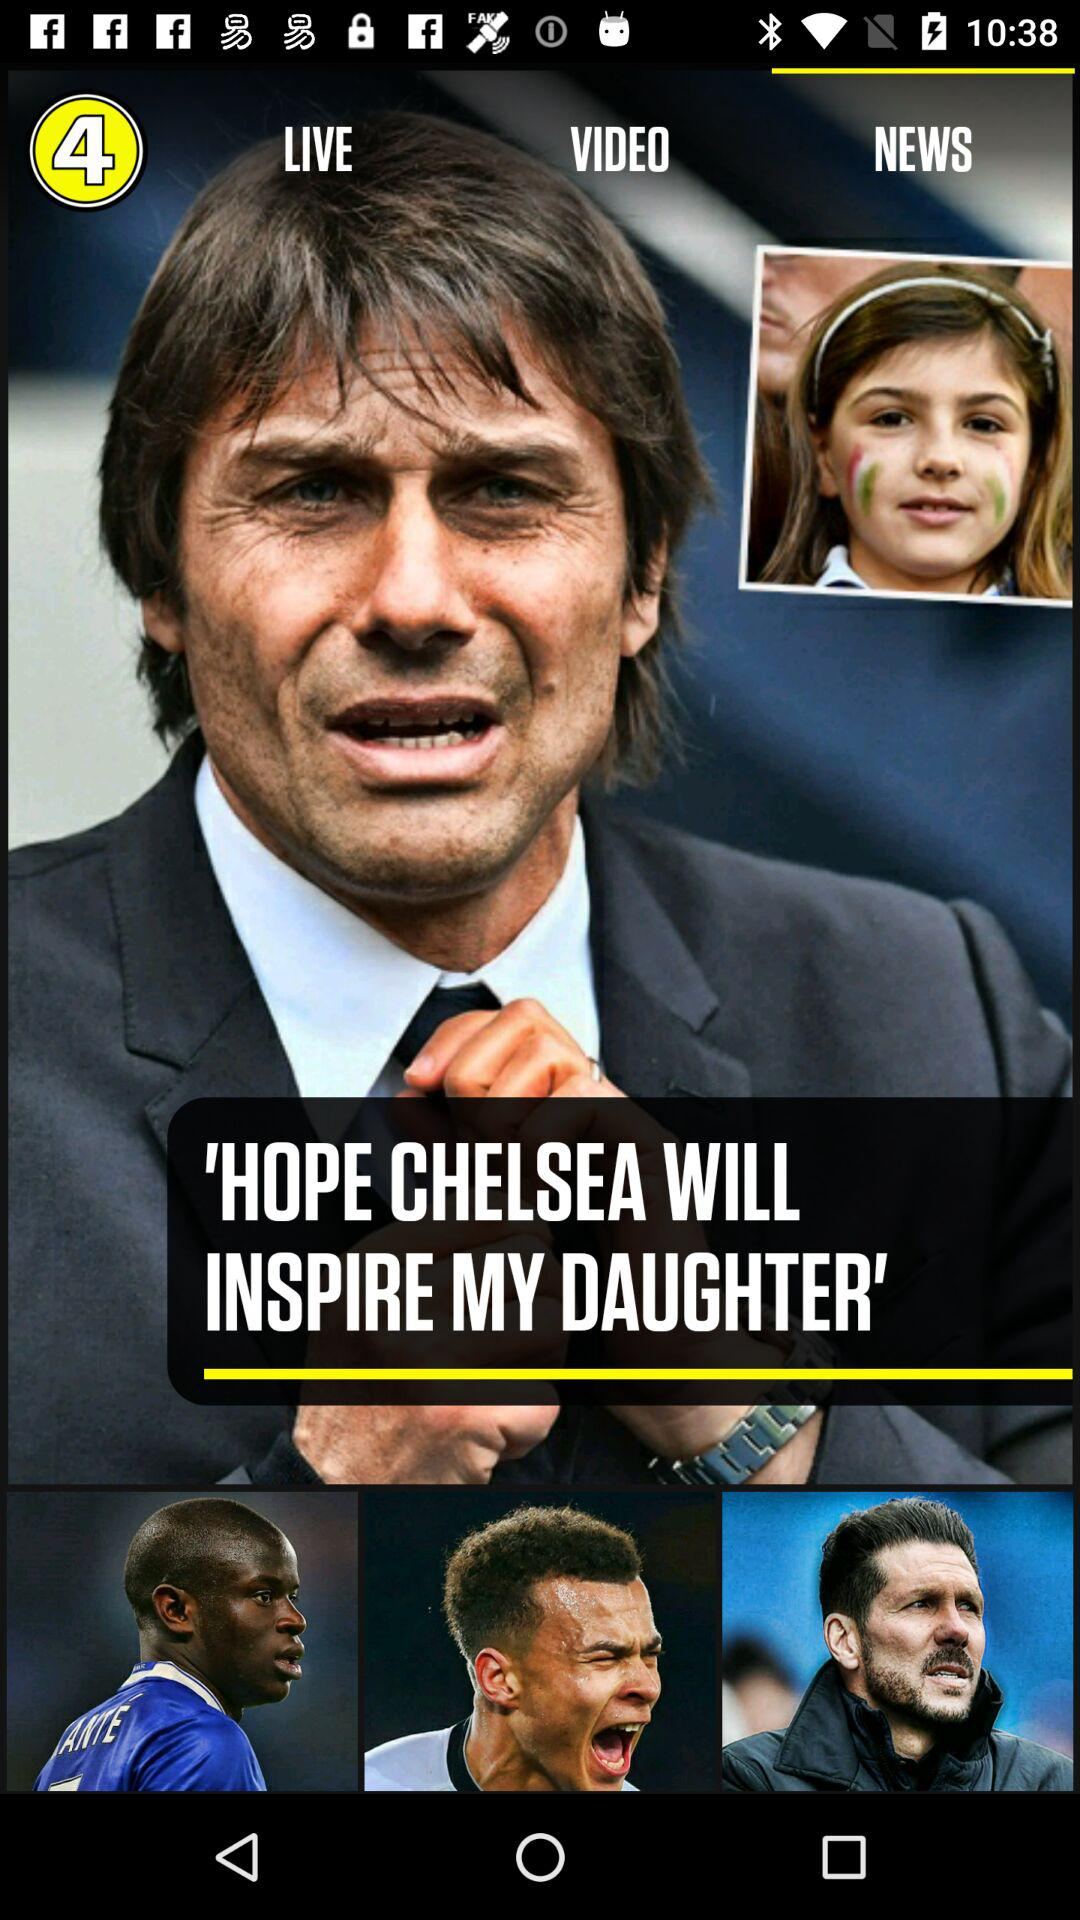Which tab is selected? The selected tab is "NEWS". 